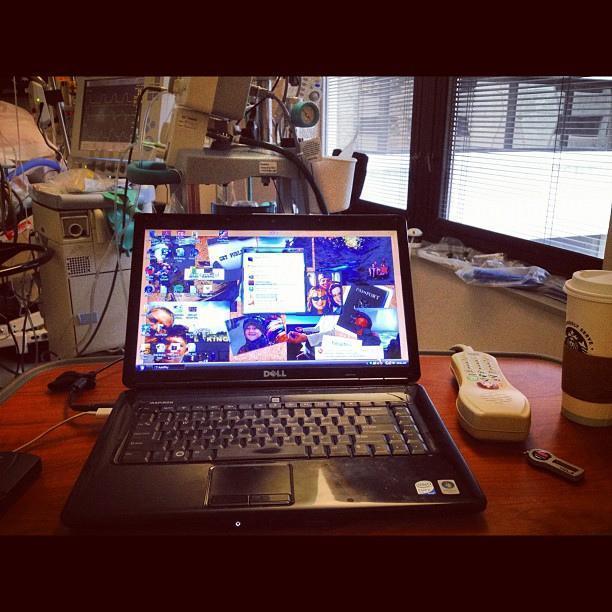How many beverages are on the table?
Give a very brief answer. 1. How many buses are pictured?
Give a very brief answer. 0. 